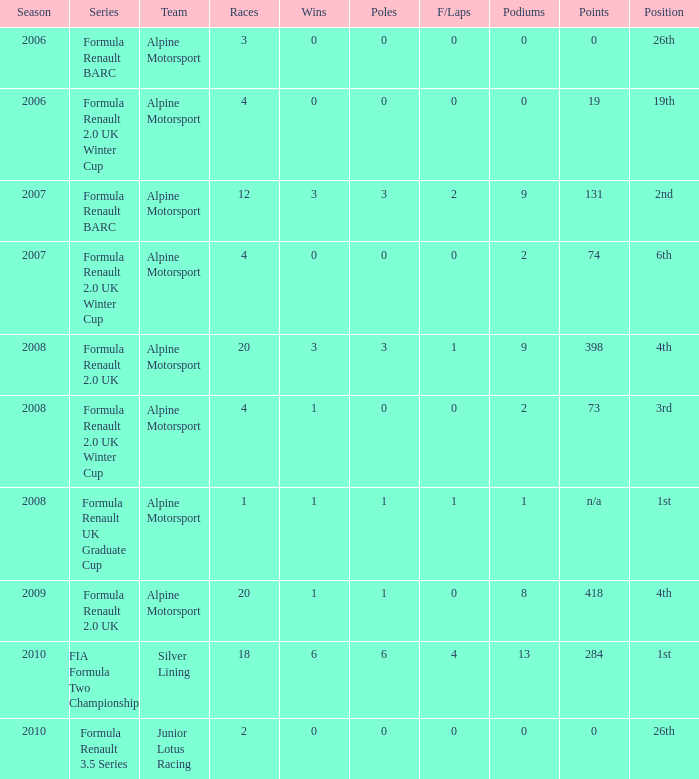In which races were there 0 fastest laps and a single pole position? 20.0. 